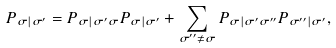<formula> <loc_0><loc_0><loc_500><loc_500>P _ { \sigma | \sigma ^ { \prime } } = P _ { \sigma | \sigma ^ { \prime } \sigma } P _ { \sigma | \sigma ^ { \prime } } + \sum _ { \sigma ^ { \prime \prime } \ne \sigma } P _ { \sigma | \sigma ^ { \prime } \sigma ^ { \prime \prime } } P _ { \sigma ^ { \prime \prime } | \sigma ^ { \prime } } ,</formula> 